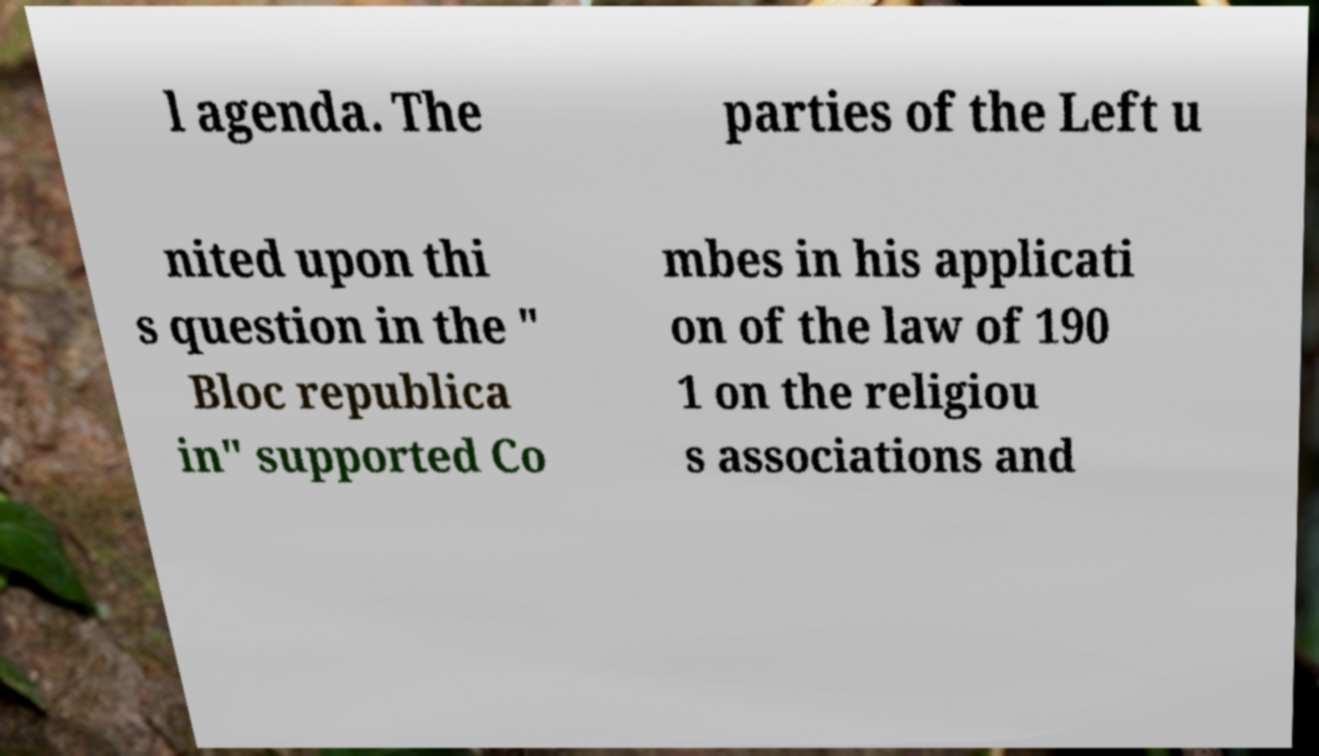Please read and relay the text visible in this image. What does it say? l agenda. The parties of the Left u nited upon thi s question in the " Bloc republica in" supported Co mbes in his applicati on of the law of 190 1 on the religiou s associations and 